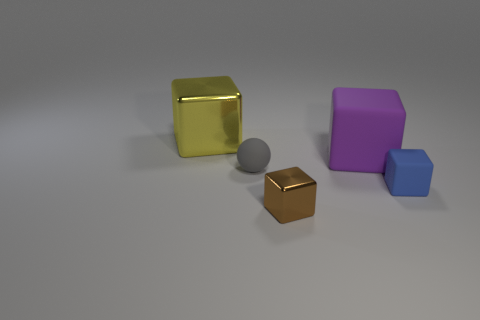Add 1 cyan shiny cylinders. How many objects exist? 6 Subtract all big metallic cubes. How many cubes are left? 3 Subtract all balls. How many objects are left? 4 Subtract 2 blocks. How many blocks are left? 2 Subtract all blue blocks. How many blocks are left? 3 Add 5 small gray balls. How many small gray balls are left? 6 Add 4 purple shiny cubes. How many purple shiny cubes exist? 4 Subtract 0 green cylinders. How many objects are left? 5 Subtract all brown spheres. Subtract all green cylinders. How many spheres are left? 1 Subtract all large cyan spheres. Subtract all big blocks. How many objects are left? 3 